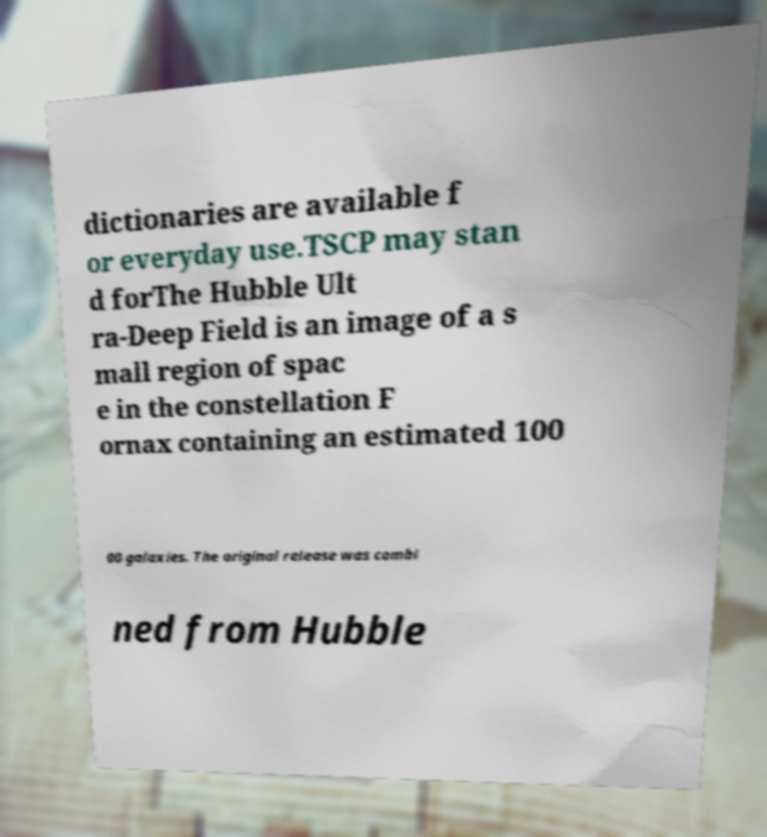Please identify and transcribe the text found in this image. dictionaries are available f or everyday use.TSCP may stan d forThe Hubble Ult ra-Deep Field is an image of a s mall region of spac e in the constellation F ornax containing an estimated 100 00 galaxies. The original release was combi ned from Hubble 